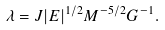Convert formula to latex. <formula><loc_0><loc_0><loc_500><loc_500>\lambda = J | E | ^ { 1 / 2 } M ^ { - 5 / 2 } G ^ { - 1 } .</formula> 